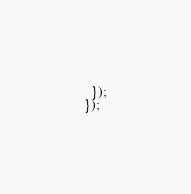Convert code to text. <code><loc_0><loc_0><loc_500><loc_500><_TypeScript_>  });
});
</code> 